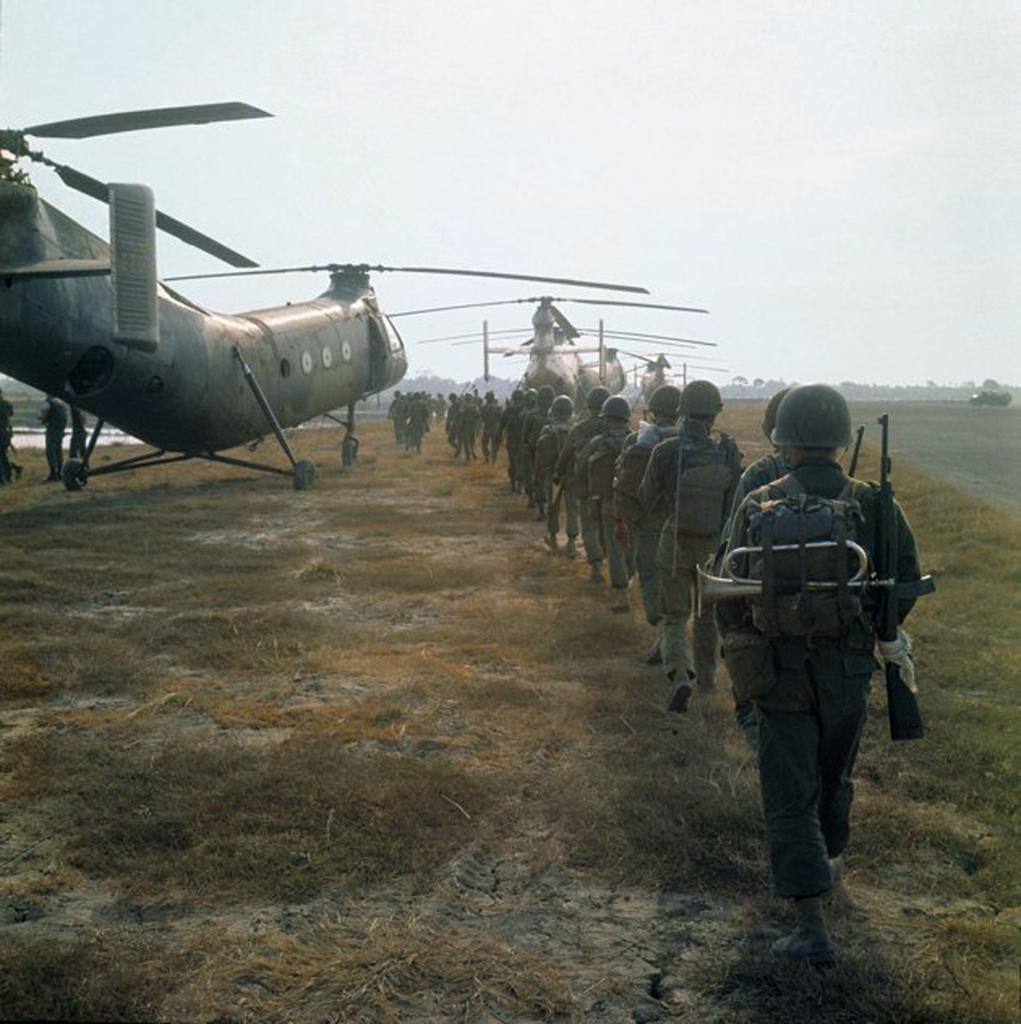What are the people in the image doing? The people in the image are walking. What are the people wearing on their bodies? The people are wearing bags. What are the people holding in their hands? The people are carrying weapons. What can be seen in the sky in the image? The sky is visible in the background of the image. What type of vegetation is present at the bottom of the image? There is dry grass at the bottom of the image. Can you see any liquid flowing in the image? There is no liquid flowing in the image. Is there a frog visible in the image? There is no frog present in the image. 